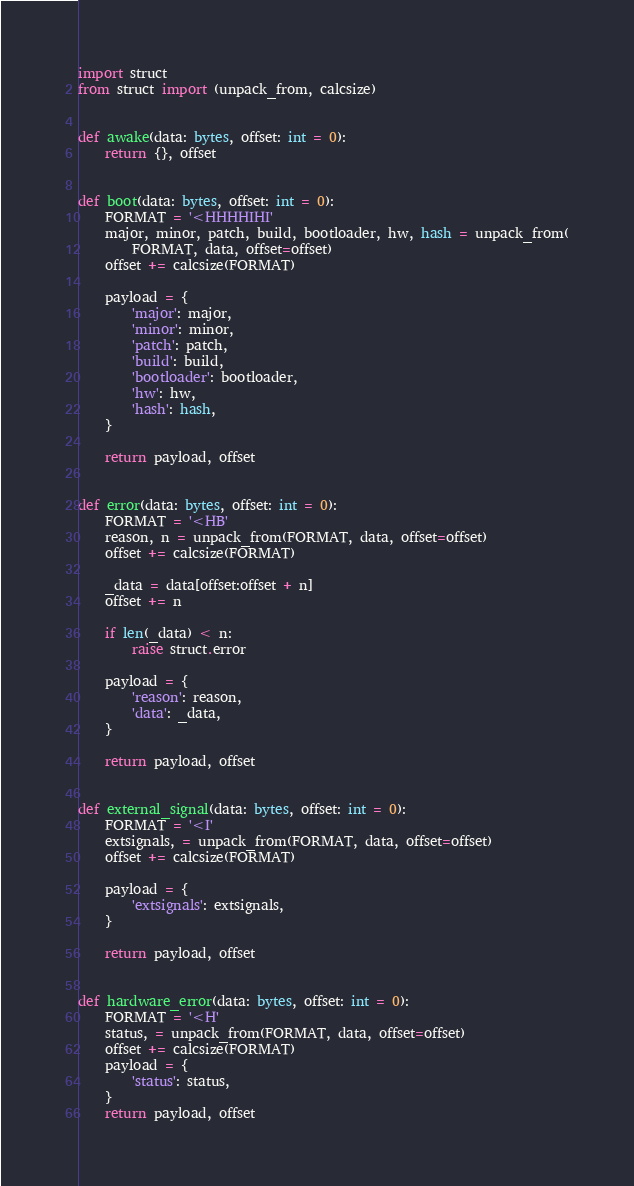Convert code to text. <code><loc_0><loc_0><loc_500><loc_500><_Python_>import struct
from struct import (unpack_from, calcsize)


def awake(data: bytes, offset: int = 0):
    return {}, offset


def boot(data: bytes, offset: int = 0):
    FORMAT = '<HHHHIHI'
    major, minor, patch, build, bootloader, hw, hash = unpack_from(
        FORMAT, data, offset=offset)
    offset += calcsize(FORMAT)

    payload = {
        'major': major,
        'minor': minor,
        'patch': patch,
        'build': build,
        'bootloader': bootloader,
        'hw': hw,
        'hash': hash,
    }

    return payload, offset


def error(data: bytes, offset: int = 0):
    FORMAT = '<HB'
    reason, n = unpack_from(FORMAT, data, offset=offset)
    offset += calcsize(FORMAT)

    _data = data[offset:offset + n]
    offset += n

    if len(_data) < n:
        raise struct.error

    payload = {
        'reason': reason,
        'data': _data,
    }

    return payload, offset


def external_signal(data: bytes, offset: int = 0):
    FORMAT = '<I'
    extsignals, = unpack_from(FORMAT, data, offset=offset)
    offset += calcsize(FORMAT)

    payload = {
        'extsignals': extsignals,
    }

    return payload, offset


def hardware_error(data: bytes, offset: int = 0):
    FORMAT = '<H'
    status, = unpack_from(FORMAT, data, offset=offset)
    offset += calcsize(FORMAT)
    payload = {
        'status': status,
    }
    return payload, offset
</code> 